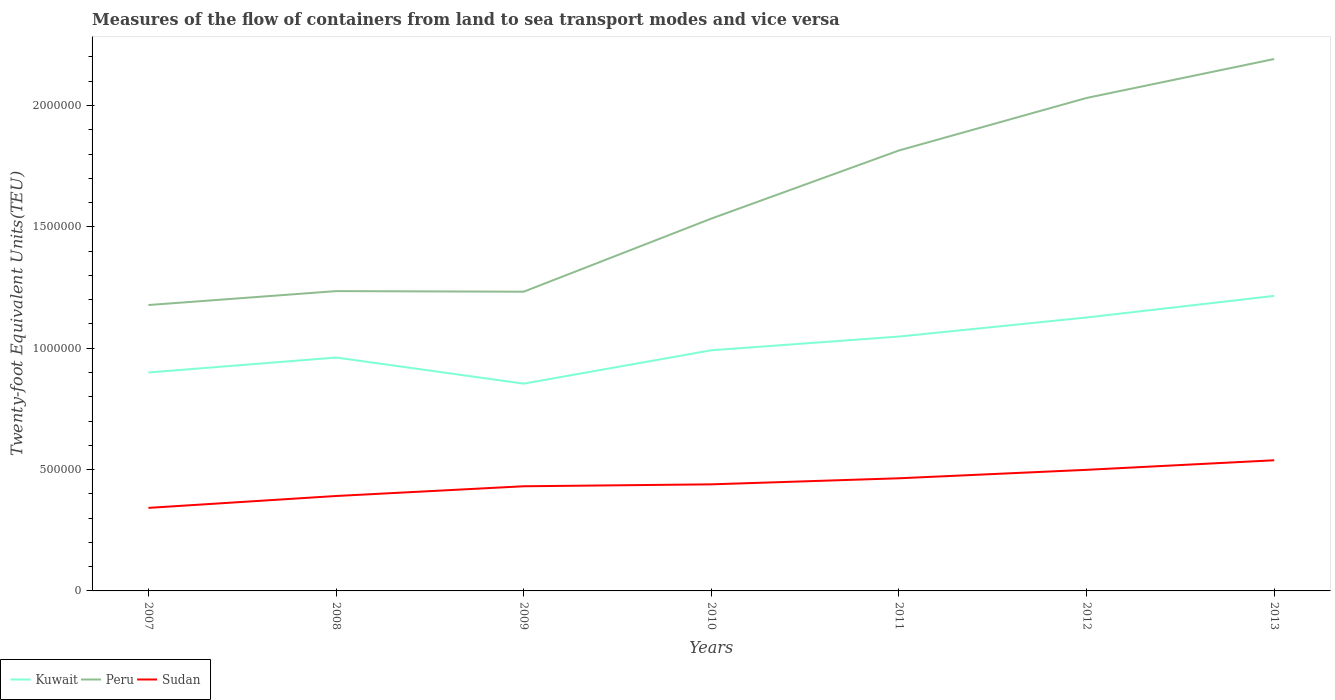Does the line corresponding to Kuwait intersect with the line corresponding to Sudan?
Your answer should be compact. No. Across all years, what is the maximum container port traffic in Kuwait?
Your response must be concise. 8.54e+05. What is the total container port traffic in Kuwait in the graph?
Your response must be concise. -1.35e+05. What is the difference between the highest and the second highest container port traffic in Peru?
Offer a very short reply. 1.01e+06. Is the container port traffic in Sudan strictly greater than the container port traffic in Peru over the years?
Your response must be concise. Yes. What is the difference between two consecutive major ticks on the Y-axis?
Give a very brief answer. 5.00e+05. Are the values on the major ticks of Y-axis written in scientific E-notation?
Your answer should be compact. No. Does the graph contain any zero values?
Your response must be concise. No. How many legend labels are there?
Make the answer very short. 3. What is the title of the graph?
Provide a succinct answer. Measures of the flow of containers from land to sea transport modes and vice versa. Does "Chad" appear as one of the legend labels in the graph?
Provide a short and direct response. No. What is the label or title of the X-axis?
Give a very brief answer. Years. What is the label or title of the Y-axis?
Make the answer very short. Twenty-foot Equivalent Units(TEU). What is the Twenty-foot Equivalent Units(TEU) of Peru in 2007?
Your answer should be compact. 1.18e+06. What is the Twenty-foot Equivalent Units(TEU) of Sudan in 2007?
Give a very brief answer. 3.42e+05. What is the Twenty-foot Equivalent Units(TEU) in Kuwait in 2008?
Keep it short and to the point. 9.62e+05. What is the Twenty-foot Equivalent Units(TEU) in Peru in 2008?
Provide a succinct answer. 1.24e+06. What is the Twenty-foot Equivalent Units(TEU) in Sudan in 2008?
Offer a terse response. 3.91e+05. What is the Twenty-foot Equivalent Units(TEU) in Kuwait in 2009?
Provide a short and direct response. 8.54e+05. What is the Twenty-foot Equivalent Units(TEU) in Peru in 2009?
Your response must be concise. 1.23e+06. What is the Twenty-foot Equivalent Units(TEU) in Sudan in 2009?
Ensure brevity in your answer.  4.31e+05. What is the Twenty-foot Equivalent Units(TEU) in Kuwait in 2010?
Provide a short and direct response. 9.92e+05. What is the Twenty-foot Equivalent Units(TEU) in Peru in 2010?
Keep it short and to the point. 1.53e+06. What is the Twenty-foot Equivalent Units(TEU) of Sudan in 2010?
Offer a terse response. 4.39e+05. What is the Twenty-foot Equivalent Units(TEU) of Kuwait in 2011?
Offer a terse response. 1.05e+06. What is the Twenty-foot Equivalent Units(TEU) in Peru in 2011?
Provide a short and direct response. 1.81e+06. What is the Twenty-foot Equivalent Units(TEU) of Sudan in 2011?
Your answer should be compact. 4.64e+05. What is the Twenty-foot Equivalent Units(TEU) in Kuwait in 2012?
Your response must be concise. 1.13e+06. What is the Twenty-foot Equivalent Units(TEU) in Peru in 2012?
Make the answer very short. 2.03e+06. What is the Twenty-foot Equivalent Units(TEU) of Sudan in 2012?
Provide a succinct answer. 4.99e+05. What is the Twenty-foot Equivalent Units(TEU) of Kuwait in 2013?
Your answer should be compact. 1.22e+06. What is the Twenty-foot Equivalent Units(TEU) in Peru in 2013?
Your answer should be compact. 2.19e+06. What is the Twenty-foot Equivalent Units(TEU) in Sudan in 2013?
Your answer should be compact. 5.38e+05. Across all years, what is the maximum Twenty-foot Equivalent Units(TEU) of Kuwait?
Your answer should be very brief. 1.22e+06. Across all years, what is the maximum Twenty-foot Equivalent Units(TEU) in Peru?
Offer a very short reply. 2.19e+06. Across all years, what is the maximum Twenty-foot Equivalent Units(TEU) of Sudan?
Your response must be concise. 5.38e+05. Across all years, what is the minimum Twenty-foot Equivalent Units(TEU) in Kuwait?
Your answer should be very brief. 8.54e+05. Across all years, what is the minimum Twenty-foot Equivalent Units(TEU) in Peru?
Provide a succinct answer. 1.18e+06. Across all years, what is the minimum Twenty-foot Equivalent Units(TEU) in Sudan?
Your response must be concise. 3.42e+05. What is the total Twenty-foot Equivalent Units(TEU) of Kuwait in the graph?
Give a very brief answer. 7.10e+06. What is the total Twenty-foot Equivalent Units(TEU) of Peru in the graph?
Ensure brevity in your answer.  1.12e+07. What is the total Twenty-foot Equivalent Units(TEU) in Sudan in the graph?
Give a very brief answer. 3.11e+06. What is the difference between the Twenty-foot Equivalent Units(TEU) of Kuwait in 2007 and that in 2008?
Give a very brief answer. -6.17e+04. What is the difference between the Twenty-foot Equivalent Units(TEU) in Peru in 2007 and that in 2008?
Your response must be concise. -5.74e+04. What is the difference between the Twenty-foot Equivalent Units(TEU) in Sudan in 2007 and that in 2008?
Your answer should be compact. -4.90e+04. What is the difference between the Twenty-foot Equivalent Units(TEU) in Kuwait in 2007 and that in 2009?
Offer a terse response. 4.60e+04. What is the difference between the Twenty-foot Equivalent Units(TEU) of Peru in 2007 and that in 2009?
Offer a very short reply. -5.49e+04. What is the difference between the Twenty-foot Equivalent Units(TEU) in Sudan in 2007 and that in 2009?
Provide a succinct answer. -8.91e+04. What is the difference between the Twenty-foot Equivalent Units(TEU) in Kuwait in 2007 and that in 2010?
Your answer should be very brief. -9.15e+04. What is the difference between the Twenty-foot Equivalent Units(TEU) in Peru in 2007 and that in 2010?
Provide a short and direct response. -3.56e+05. What is the difference between the Twenty-foot Equivalent Units(TEU) of Sudan in 2007 and that in 2010?
Your response must be concise. -9.69e+04. What is the difference between the Twenty-foot Equivalent Units(TEU) of Kuwait in 2007 and that in 2011?
Your response must be concise. -1.48e+05. What is the difference between the Twenty-foot Equivalent Units(TEU) of Peru in 2007 and that in 2011?
Your response must be concise. -6.37e+05. What is the difference between the Twenty-foot Equivalent Units(TEU) in Sudan in 2007 and that in 2011?
Keep it short and to the point. -1.22e+05. What is the difference between the Twenty-foot Equivalent Units(TEU) of Kuwait in 2007 and that in 2012?
Your answer should be compact. -2.27e+05. What is the difference between the Twenty-foot Equivalent Units(TEU) of Peru in 2007 and that in 2012?
Provide a succinct answer. -8.53e+05. What is the difference between the Twenty-foot Equivalent Units(TEU) in Sudan in 2007 and that in 2012?
Your response must be concise. -1.57e+05. What is the difference between the Twenty-foot Equivalent Units(TEU) of Kuwait in 2007 and that in 2013?
Ensure brevity in your answer.  -3.16e+05. What is the difference between the Twenty-foot Equivalent Units(TEU) of Peru in 2007 and that in 2013?
Your answer should be very brief. -1.01e+06. What is the difference between the Twenty-foot Equivalent Units(TEU) in Sudan in 2007 and that in 2013?
Make the answer very short. -1.96e+05. What is the difference between the Twenty-foot Equivalent Units(TEU) in Kuwait in 2008 and that in 2009?
Provide a succinct answer. 1.08e+05. What is the difference between the Twenty-foot Equivalent Units(TEU) of Peru in 2008 and that in 2009?
Your response must be concise. 2477. What is the difference between the Twenty-foot Equivalent Units(TEU) in Sudan in 2008 and that in 2009?
Your response must be concise. -4.01e+04. What is the difference between the Twenty-foot Equivalent Units(TEU) of Kuwait in 2008 and that in 2010?
Your response must be concise. -2.99e+04. What is the difference between the Twenty-foot Equivalent Units(TEU) in Peru in 2008 and that in 2010?
Provide a succinct answer. -2.99e+05. What is the difference between the Twenty-foot Equivalent Units(TEU) in Sudan in 2008 and that in 2010?
Your answer should be compact. -4.80e+04. What is the difference between the Twenty-foot Equivalent Units(TEU) of Kuwait in 2008 and that in 2011?
Give a very brief answer. -8.64e+04. What is the difference between the Twenty-foot Equivalent Units(TEU) of Peru in 2008 and that in 2011?
Keep it short and to the point. -5.79e+05. What is the difference between the Twenty-foot Equivalent Units(TEU) in Sudan in 2008 and that in 2011?
Your response must be concise. -7.30e+04. What is the difference between the Twenty-foot Equivalent Units(TEU) in Kuwait in 2008 and that in 2012?
Keep it short and to the point. -1.65e+05. What is the difference between the Twenty-foot Equivalent Units(TEU) in Peru in 2008 and that in 2012?
Provide a short and direct response. -7.96e+05. What is the difference between the Twenty-foot Equivalent Units(TEU) in Sudan in 2008 and that in 2012?
Your response must be concise. -1.08e+05. What is the difference between the Twenty-foot Equivalent Units(TEU) in Kuwait in 2008 and that in 2013?
Your response must be concise. -2.54e+05. What is the difference between the Twenty-foot Equivalent Units(TEU) in Peru in 2008 and that in 2013?
Make the answer very short. -9.56e+05. What is the difference between the Twenty-foot Equivalent Units(TEU) of Sudan in 2008 and that in 2013?
Your response must be concise. -1.47e+05. What is the difference between the Twenty-foot Equivalent Units(TEU) of Kuwait in 2009 and that in 2010?
Keep it short and to the point. -1.38e+05. What is the difference between the Twenty-foot Equivalent Units(TEU) of Peru in 2009 and that in 2010?
Make the answer very short. -3.01e+05. What is the difference between the Twenty-foot Equivalent Units(TEU) of Sudan in 2009 and that in 2010?
Offer a very short reply. -7868. What is the difference between the Twenty-foot Equivalent Units(TEU) in Kuwait in 2009 and that in 2011?
Your answer should be very brief. -1.94e+05. What is the difference between the Twenty-foot Equivalent Units(TEU) of Peru in 2009 and that in 2011?
Your answer should be very brief. -5.82e+05. What is the difference between the Twenty-foot Equivalent Units(TEU) of Sudan in 2009 and that in 2011?
Keep it short and to the point. -3.29e+04. What is the difference between the Twenty-foot Equivalent Units(TEU) of Kuwait in 2009 and that in 2012?
Your answer should be compact. -2.73e+05. What is the difference between the Twenty-foot Equivalent Units(TEU) of Peru in 2009 and that in 2012?
Provide a short and direct response. -7.98e+05. What is the difference between the Twenty-foot Equivalent Units(TEU) of Sudan in 2009 and that in 2012?
Provide a succinct answer. -6.77e+04. What is the difference between the Twenty-foot Equivalent Units(TEU) in Kuwait in 2009 and that in 2013?
Keep it short and to the point. -3.62e+05. What is the difference between the Twenty-foot Equivalent Units(TEU) in Peru in 2009 and that in 2013?
Provide a succinct answer. -9.59e+05. What is the difference between the Twenty-foot Equivalent Units(TEU) in Sudan in 2009 and that in 2013?
Your answer should be compact. -1.07e+05. What is the difference between the Twenty-foot Equivalent Units(TEU) in Kuwait in 2010 and that in 2011?
Make the answer very short. -5.65e+04. What is the difference between the Twenty-foot Equivalent Units(TEU) of Peru in 2010 and that in 2011?
Give a very brief answer. -2.81e+05. What is the difference between the Twenty-foot Equivalent Units(TEU) of Sudan in 2010 and that in 2011?
Provide a succinct answer. -2.50e+04. What is the difference between the Twenty-foot Equivalent Units(TEU) in Kuwait in 2010 and that in 2012?
Ensure brevity in your answer.  -1.35e+05. What is the difference between the Twenty-foot Equivalent Units(TEU) in Peru in 2010 and that in 2012?
Your response must be concise. -4.97e+05. What is the difference between the Twenty-foot Equivalent Units(TEU) of Sudan in 2010 and that in 2012?
Make the answer very short. -5.98e+04. What is the difference between the Twenty-foot Equivalent Units(TEU) in Kuwait in 2010 and that in 2013?
Your answer should be compact. -2.24e+05. What is the difference between the Twenty-foot Equivalent Units(TEU) of Peru in 2010 and that in 2013?
Provide a short and direct response. -6.58e+05. What is the difference between the Twenty-foot Equivalent Units(TEU) of Sudan in 2010 and that in 2013?
Your answer should be very brief. -9.93e+04. What is the difference between the Twenty-foot Equivalent Units(TEU) of Kuwait in 2011 and that in 2012?
Provide a short and direct response. -7.86e+04. What is the difference between the Twenty-foot Equivalent Units(TEU) of Peru in 2011 and that in 2012?
Your answer should be compact. -2.16e+05. What is the difference between the Twenty-foot Equivalent Units(TEU) in Sudan in 2011 and that in 2012?
Make the answer very short. -3.48e+04. What is the difference between the Twenty-foot Equivalent Units(TEU) in Kuwait in 2011 and that in 2013?
Provide a short and direct response. -1.68e+05. What is the difference between the Twenty-foot Equivalent Units(TEU) in Peru in 2011 and that in 2013?
Your response must be concise. -3.77e+05. What is the difference between the Twenty-foot Equivalent Units(TEU) of Sudan in 2011 and that in 2013?
Offer a terse response. -7.42e+04. What is the difference between the Twenty-foot Equivalent Units(TEU) in Kuwait in 2012 and that in 2013?
Your response must be concise. -8.90e+04. What is the difference between the Twenty-foot Equivalent Units(TEU) in Peru in 2012 and that in 2013?
Offer a terse response. -1.60e+05. What is the difference between the Twenty-foot Equivalent Units(TEU) of Sudan in 2012 and that in 2013?
Ensure brevity in your answer.  -3.94e+04. What is the difference between the Twenty-foot Equivalent Units(TEU) in Kuwait in 2007 and the Twenty-foot Equivalent Units(TEU) in Peru in 2008?
Your response must be concise. -3.35e+05. What is the difference between the Twenty-foot Equivalent Units(TEU) in Kuwait in 2007 and the Twenty-foot Equivalent Units(TEU) in Sudan in 2008?
Your answer should be compact. 5.09e+05. What is the difference between the Twenty-foot Equivalent Units(TEU) in Peru in 2007 and the Twenty-foot Equivalent Units(TEU) in Sudan in 2008?
Offer a terse response. 7.87e+05. What is the difference between the Twenty-foot Equivalent Units(TEU) in Kuwait in 2007 and the Twenty-foot Equivalent Units(TEU) in Peru in 2009?
Your answer should be very brief. -3.33e+05. What is the difference between the Twenty-foot Equivalent Units(TEU) in Kuwait in 2007 and the Twenty-foot Equivalent Units(TEU) in Sudan in 2009?
Offer a very short reply. 4.69e+05. What is the difference between the Twenty-foot Equivalent Units(TEU) in Peru in 2007 and the Twenty-foot Equivalent Units(TEU) in Sudan in 2009?
Make the answer very short. 7.47e+05. What is the difference between the Twenty-foot Equivalent Units(TEU) in Kuwait in 2007 and the Twenty-foot Equivalent Units(TEU) in Peru in 2010?
Keep it short and to the point. -6.34e+05. What is the difference between the Twenty-foot Equivalent Units(TEU) of Kuwait in 2007 and the Twenty-foot Equivalent Units(TEU) of Sudan in 2010?
Provide a short and direct response. 4.61e+05. What is the difference between the Twenty-foot Equivalent Units(TEU) in Peru in 2007 and the Twenty-foot Equivalent Units(TEU) in Sudan in 2010?
Offer a terse response. 7.39e+05. What is the difference between the Twenty-foot Equivalent Units(TEU) of Kuwait in 2007 and the Twenty-foot Equivalent Units(TEU) of Peru in 2011?
Provide a short and direct response. -9.15e+05. What is the difference between the Twenty-foot Equivalent Units(TEU) of Kuwait in 2007 and the Twenty-foot Equivalent Units(TEU) of Sudan in 2011?
Offer a very short reply. 4.36e+05. What is the difference between the Twenty-foot Equivalent Units(TEU) in Peru in 2007 and the Twenty-foot Equivalent Units(TEU) in Sudan in 2011?
Make the answer very short. 7.14e+05. What is the difference between the Twenty-foot Equivalent Units(TEU) in Kuwait in 2007 and the Twenty-foot Equivalent Units(TEU) in Peru in 2012?
Provide a succinct answer. -1.13e+06. What is the difference between the Twenty-foot Equivalent Units(TEU) of Kuwait in 2007 and the Twenty-foot Equivalent Units(TEU) of Sudan in 2012?
Offer a very short reply. 4.01e+05. What is the difference between the Twenty-foot Equivalent Units(TEU) of Peru in 2007 and the Twenty-foot Equivalent Units(TEU) of Sudan in 2012?
Your answer should be very brief. 6.79e+05. What is the difference between the Twenty-foot Equivalent Units(TEU) in Kuwait in 2007 and the Twenty-foot Equivalent Units(TEU) in Peru in 2013?
Your answer should be very brief. -1.29e+06. What is the difference between the Twenty-foot Equivalent Units(TEU) of Kuwait in 2007 and the Twenty-foot Equivalent Units(TEU) of Sudan in 2013?
Make the answer very short. 3.62e+05. What is the difference between the Twenty-foot Equivalent Units(TEU) in Peru in 2007 and the Twenty-foot Equivalent Units(TEU) in Sudan in 2013?
Provide a short and direct response. 6.40e+05. What is the difference between the Twenty-foot Equivalent Units(TEU) in Kuwait in 2008 and the Twenty-foot Equivalent Units(TEU) in Peru in 2009?
Offer a very short reply. -2.71e+05. What is the difference between the Twenty-foot Equivalent Units(TEU) of Kuwait in 2008 and the Twenty-foot Equivalent Units(TEU) of Sudan in 2009?
Provide a succinct answer. 5.30e+05. What is the difference between the Twenty-foot Equivalent Units(TEU) in Peru in 2008 and the Twenty-foot Equivalent Units(TEU) in Sudan in 2009?
Your answer should be compact. 8.04e+05. What is the difference between the Twenty-foot Equivalent Units(TEU) of Kuwait in 2008 and the Twenty-foot Equivalent Units(TEU) of Peru in 2010?
Offer a terse response. -5.72e+05. What is the difference between the Twenty-foot Equivalent Units(TEU) of Kuwait in 2008 and the Twenty-foot Equivalent Units(TEU) of Sudan in 2010?
Give a very brief answer. 5.23e+05. What is the difference between the Twenty-foot Equivalent Units(TEU) in Peru in 2008 and the Twenty-foot Equivalent Units(TEU) in Sudan in 2010?
Provide a succinct answer. 7.96e+05. What is the difference between the Twenty-foot Equivalent Units(TEU) of Kuwait in 2008 and the Twenty-foot Equivalent Units(TEU) of Peru in 2011?
Your answer should be very brief. -8.53e+05. What is the difference between the Twenty-foot Equivalent Units(TEU) in Kuwait in 2008 and the Twenty-foot Equivalent Units(TEU) in Sudan in 2011?
Provide a succinct answer. 4.98e+05. What is the difference between the Twenty-foot Equivalent Units(TEU) in Peru in 2008 and the Twenty-foot Equivalent Units(TEU) in Sudan in 2011?
Give a very brief answer. 7.71e+05. What is the difference between the Twenty-foot Equivalent Units(TEU) in Kuwait in 2008 and the Twenty-foot Equivalent Units(TEU) in Peru in 2012?
Make the answer very short. -1.07e+06. What is the difference between the Twenty-foot Equivalent Units(TEU) of Kuwait in 2008 and the Twenty-foot Equivalent Units(TEU) of Sudan in 2012?
Provide a succinct answer. 4.63e+05. What is the difference between the Twenty-foot Equivalent Units(TEU) in Peru in 2008 and the Twenty-foot Equivalent Units(TEU) in Sudan in 2012?
Your response must be concise. 7.36e+05. What is the difference between the Twenty-foot Equivalent Units(TEU) of Kuwait in 2008 and the Twenty-foot Equivalent Units(TEU) of Peru in 2013?
Offer a terse response. -1.23e+06. What is the difference between the Twenty-foot Equivalent Units(TEU) of Kuwait in 2008 and the Twenty-foot Equivalent Units(TEU) of Sudan in 2013?
Provide a short and direct response. 4.23e+05. What is the difference between the Twenty-foot Equivalent Units(TEU) of Peru in 2008 and the Twenty-foot Equivalent Units(TEU) of Sudan in 2013?
Make the answer very short. 6.97e+05. What is the difference between the Twenty-foot Equivalent Units(TEU) in Kuwait in 2009 and the Twenty-foot Equivalent Units(TEU) in Peru in 2010?
Provide a short and direct response. -6.80e+05. What is the difference between the Twenty-foot Equivalent Units(TEU) in Kuwait in 2009 and the Twenty-foot Equivalent Units(TEU) in Sudan in 2010?
Offer a very short reply. 4.15e+05. What is the difference between the Twenty-foot Equivalent Units(TEU) of Peru in 2009 and the Twenty-foot Equivalent Units(TEU) of Sudan in 2010?
Ensure brevity in your answer.  7.94e+05. What is the difference between the Twenty-foot Equivalent Units(TEU) of Kuwait in 2009 and the Twenty-foot Equivalent Units(TEU) of Peru in 2011?
Keep it short and to the point. -9.61e+05. What is the difference between the Twenty-foot Equivalent Units(TEU) of Kuwait in 2009 and the Twenty-foot Equivalent Units(TEU) of Sudan in 2011?
Provide a short and direct response. 3.90e+05. What is the difference between the Twenty-foot Equivalent Units(TEU) in Peru in 2009 and the Twenty-foot Equivalent Units(TEU) in Sudan in 2011?
Your response must be concise. 7.69e+05. What is the difference between the Twenty-foot Equivalent Units(TEU) in Kuwait in 2009 and the Twenty-foot Equivalent Units(TEU) in Peru in 2012?
Make the answer very short. -1.18e+06. What is the difference between the Twenty-foot Equivalent Units(TEU) of Kuwait in 2009 and the Twenty-foot Equivalent Units(TEU) of Sudan in 2012?
Provide a succinct answer. 3.55e+05. What is the difference between the Twenty-foot Equivalent Units(TEU) in Peru in 2009 and the Twenty-foot Equivalent Units(TEU) in Sudan in 2012?
Offer a terse response. 7.34e+05. What is the difference between the Twenty-foot Equivalent Units(TEU) of Kuwait in 2009 and the Twenty-foot Equivalent Units(TEU) of Peru in 2013?
Your response must be concise. -1.34e+06. What is the difference between the Twenty-foot Equivalent Units(TEU) in Kuwait in 2009 and the Twenty-foot Equivalent Units(TEU) in Sudan in 2013?
Make the answer very short. 3.16e+05. What is the difference between the Twenty-foot Equivalent Units(TEU) of Peru in 2009 and the Twenty-foot Equivalent Units(TEU) of Sudan in 2013?
Provide a short and direct response. 6.94e+05. What is the difference between the Twenty-foot Equivalent Units(TEU) of Kuwait in 2010 and the Twenty-foot Equivalent Units(TEU) of Peru in 2011?
Offer a very short reply. -8.23e+05. What is the difference between the Twenty-foot Equivalent Units(TEU) in Kuwait in 2010 and the Twenty-foot Equivalent Units(TEU) in Sudan in 2011?
Your response must be concise. 5.27e+05. What is the difference between the Twenty-foot Equivalent Units(TEU) of Peru in 2010 and the Twenty-foot Equivalent Units(TEU) of Sudan in 2011?
Keep it short and to the point. 1.07e+06. What is the difference between the Twenty-foot Equivalent Units(TEU) in Kuwait in 2010 and the Twenty-foot Equivalent Units(TEU) in Peru in 2012?
Your answer should be compact. -1.04e+06. What is the difference between the Twenty-foot Equivalent Units(TEU) in Kuwait in 2010 and the Twenty-foot Equivalent Units(TEU) in Sudan in 2012?
Provide a short and direct response. 4.93e+05. What is the difference between the Twenty-foot Equivalent Units(TEU) in Peru in 2010 and the Twenty-foot Equivalent Units(TEU) in Sudan in 2012?
Ensure brevity in your answer.  1.04e+06. What is the difference between the Twenty-foot Equivalent Units(TEU) in Kuwait in 2010 and the Twenty-foot Equivalent Units(TEU) in Peru in 2013?
Your response must be concise. -1.20e+06. What is the difference between the Twenty-foot Equivalent Units(TEU) of Kuwait in 2010 and the Twenty-foot Equivalent Units(TEU) of Sudan in 2013?
Provide a succinct answer. 4.53e+05. What is the difference between the Twenty-foot Equivalent Units(TEU) in Peru in 2010 and the Twenty-foot Equivalent Units(TEU) in Sudan in 2013?
Your answer should be compact. 9.96e+05. What is the difference between the Twenty-foot Equivalent Units(TEU) in Kuwait in 2011 and the Twenty-foot Equivalent Units(TEU) in Peru in 2012?
Offer a terse response. -9.83e+05. What is the difference between the Twenty-foot Equivalent Units(TEU) in Kuwait in 2011 and the Twenty-foot Equivalent Units(TEU) in Sudan in 2012?
Make the answer very short. 5.49e+05. What is the difference between the Twenty-foot Equivalent Units(TEU) in Peru in 2011 and the Twenty-foot Equivalent Units(TEU) in Sudan in 2012?
Give a very brief answer. 1.32e+06. What is the difference between the Twenty-foot Equivalent Units(TEU) of Kuwait in 2011 and the Twenty-foot Equivalent Units(TEU) of Peru in 2013?
Make the answer very short. -1.14e+06. What is the difference between the Twenty-foot Equivalent Units(TEU) of Kuwait in 2011 and the Twenty-foot Equivalent Units(TEU) of Sudan in 2013?
Offer a terse response. 5.10e+05. What is the difference between the Twenty-foot Equivalent Units(TEU) of Peru in 2011 and the Twenty-foot Equivalent Units(TEU) of Sudan in 2013?
Offer a very short reply. 1.28e+06. What is the difference between the Twenty-foot Equivalent Units(TEU) of Kuwait in 2012 and the Twenty-foot Equivalent Units(TEU) of Peru in 2013?
Provide a short and direct response. -1.06e+06. What is the difference between the Twenty-foot Equivalent Units(TEU) in Kuwait in 2012 and the Twenty-foot Equivalent Units(TEU) in Sudan in 2013?
Your response must be concise. 5.88e+05. What is the difference between the Twenty-foot Equivalent Units(TEU) of Peru in 2012 and the Twenty-foot Equivalent Units(TEU) of Sudan in 2013?
Provide a succinct answer. 1.49e+06. What is the average Twenty-foot Equivalent Units(TEU) in Kuwait per year?
Offer a very short reply. 1.01e+06. What is the average Twenty-foot Equivalent Units(TEU) in Peru per year?
Ensure brevity in your answer.  1.60e+06. What is the average Twenty-foot Equivalent Units(TEU) in Sudan per year?
Your answer should be compact. 4.44e+05. In the year 2007, what is the difference between the Twenty-foot Equivalent Units(TEU) of Kuwait and Twenty-foot Equivalent Units(TEU) of Peru?
Keep it short and to the point. -2.78e+05. In the year 2007, what is the difference between the Twenty-foot Equivalent Units(TEU) in Kuwait and Twenty-foot Equivalent Units(TEU) in Sudan?
Ensure brevity in your answer.  5.58e+05. In the year 2007, what is the difference between the Twenty-foot Equivalent Units(TEU) of Peru and Twenty-foot Equivalent Units(TEU) of Sudan?
Keep it short and to the point. 8.36e+05. In the year 2008, what is the difference between the Twenty-foot Equivalent Units(TEU) of Kuwait and Twenty-foot Equivalent Units(TEU) of Peru?
Offer a terse response. -2.74e+05. In the year 2008, what is the difference between the Twenty-foot Equivalent Units(TEU) of Kuwait and Twenty-foot Equivalent Units(TEU) of Sudan?
Your answer should be very brief. 5.71e+05. In the year 2008, what is the difference between the Twenty-foot Equivalent Units(TEU) in Peru and Twenty-foot Equivalent Units(TEU) in Sudan?
Your answer should be compact. 8.44e+05. In the year 2009, what is the difference between the Twenty-foot Equivalent Units(TEU) in Kuwait and Twenty-foot Equivalent Units(TEU) in Peru?
Your answer should be very brief. -3.79e+05. In the year 2009, what is the difference between the Twenty-foot Equivalent Units(TEU) of Kuwait and Twenty-foot Equivalent Units(TEU) of Sudan?
Make the answer very short. 4.23e+05. In the year 2009, what is the difference between the Twenty-foot Equivalent Units(TEU) of Peru and Twenty-foot Equivalent Units(TEU) of Sudan?
Provide a short and direct response. 8.02e+05. In the year 2010, what is the difference between the Twenty-foot Equivalent Units(TEU) in Kuwait and Twenty-foot Equivalent Units(TEU) in Peru?
Provide a short and direct response. -5.43e+05. In the year 2010, what is the difference between the Twenty-foot Equivalent Units(TEU) of Kuwait and Twenty-foot Equivalent Units(TEU) of Sudan?
Keep it short and to the point. 5.52e+05. In the year 2010, what is the difference between the Twenty-foot Equivalent Units(TEU) in Peru and Twenty-foot Equivalent Units(TEU) in Sudan?
Make the answer very short. 1.09e+06. In the year 2011, what is the difference between the Twenty-foot Equivalent Units(TEU) of Kuwait and Twenty-foot Equivalent Units(TEU) of Peru?
Give a very brief answer. -7.67e+05. In the year 2011, what is the difference between the Twenty-foot Equivalent Units(TEU) of Kuwait and Twenty-foot Equivalent Units(TEU) of Sudan?
Your response must be concise. 5.84e+05. In the year 2011, what is the difference between the Twenty-foot Equivalent Units(TEU) of Peru and Twenty-foot Equivalent Units(TEU) of Sudan?
Keep it short and to the point. 1.35e+06. In the year 2012, what is the difference between the Twenty-foot Equivalent Units(TEU) of Kuwait and Twenty-foot Equivalent Units(TEU) of Peru?
Ensure brevity in your answer.  -9.04e+05. In the year 2012, what is the difference between the Twenty-foot Equivalent Units(TEU) of Kuwait and Twenty-foot Equivalent Units(TEU) of Sudan?
Offer a terse response. 6.28e+05. In the year 2012, what is the difference between the Twenty-foot Equivalent Units(TEU) of Peru and Twenty-foot Equivalent Units(TEU) of Sudan?
Give a very brief answer. 1.53e+06. In the year 2013, what is the difference between the Twenty-foot Equivalent Units(TEU) of Kuwait and Twenty-foot Equivalent Units(TEU) of Peru?
Provide a succinct answer. -9.76e+05. In the year 2013, what is the difference between the Twenty-foot Equivalent Units(TEU) in Kuwait and Twenty-foot Equivalent Units(TEU) in Sudan?
Your answer should be compact. 6.77e+05. In the year 2013, what is the difference between the Twenty-foot Equivalent Units(TEU) in Peru and Twenty-foot Equivalent Units(TEU) in Sudan?
Keep it short and to the point. 1.65e+06. What is the ratio of the Twenty-foot Equivalent Units(TEU) of Kuwait in 2007 to that in 2008?
Offer a very short reply. 0.94. What is the ratio of the Twenty-foot Equivalent Units(TEU) of Peru in 2007 to that in 2008?
Give a very brief answer. 0.95. What is the ratio of the Twenty-foot Equivalent Units(TEU) in Sudan in 2007 to that in 2008?
Make the answer very short. 0.87. What is the ratio of the Twenty-foot Equivalent Units(TEU) in Kuwait in 2007 to that in 2009?
Give a very brief answer. 1.05. What is the ratio of the Twenty-foot Equivalent Units(TEU) in Peru in 2007 to that in 2009?
Offer a very short reply. 0.96. What is the ratio of the Twenty-foot Equivalent Units(TEU) of Sudan in 2007 to that in 2009?
Make the answer very short. 0.79. What is the ratio of the Twenty-foot Equivalent Units(TEU) of Kuwait in 2007 to that in 2010?
Your answer should be very brief. 0.91. What is the ratio of the Twenty-foot Equivalent Units(TEU) of Peru in 2007 to that in 2010?
Your response must be concise. 0.77. What is the ratio of the Twenty-foot Equivalent Units(TEU) in Sudan in 2007 to that in 2010?
Keep it short and to the point. 0.78. What is the ratio of the Twenty-foot Equivalent Units(TEU) in Kuwait in 2007 to that in 2011?
Your response must be concise. 0.86. What is the ratio of the Twenty-foot Equivalent Units(TEU) of Peru in 2007 to that in 2011?
Offer a terse response. 0.65. What is the ratio of the Twenty-foot Equivalent Units(TEU) in Sudan in 2007 to that in 2011?
Give a very brief answer. 0.74. What is the ratio of the Twenty-foot Equivalent Units(TEU) in Kuwait in 2007 to that in 2012?
Provide a succinct answer. 0.8. What is the ratio of the Twenty-foot Equivalent Units(TEU) of Peru in 2007 to that in 2012?
Give a very brief answer. 0.58. What is the ratio of the Twenty-foot Equivalent Units(TEU) of Sudan in 2007 to that in 2012?
Provide a succinct answer. 0.69. What is the ratio of the Twenty-foot Equivalent Units(TEU) of Kuwait in 2007 to that in 2013?
Provide a short and direct response. 0.74. What is the ratio of the Twenty-foot Equivalent Units(TEU) in Peru in 2007 to that in 2013?
Provide a short and direct response. 0.54. What is the ratio of the Twenty-foot Equivalent Units(TEU) of Sudan in 2007 to that in 2013?
Provide a succinct answer. 0.64. What is the ratio of the Twenty-foot Equivalent Units(TEU) of Kuwait in 2008 to that in 2009?
Your answer should be very brief. 1.13. What is the ratio of the Twenty-foot Equivalent Units(TEU) of Sudan in 2008 to that in 2009?
Provide a short and direct response. 0.91. What is the ratio of the Twenty-foot Equivalent Units(TEU) in Kuwait in 2008 to that in 2010?
Make the answer very short. 0.97. What is the ratio of the Twenty-foot Equivalent Units(TEU) in Peru in 2008 to that in 2010?
Your answer should be very brief. 0.81. What is the ratio of the Twenty-foot Equivalent Units(TEU) of Sudan in 2008 to that in 2010?
Your answer should be compact. 0.89. What is the ratio of the Twenty-foot Equivalent Units(TEU) of Kuwait in 2008 to that in 2011?
Keep it short and to the point. 0.92. What is the ratio of the Twenty-foot Equivalent Units(TEU) of Peru in 2008 to that in 2011?
Your answer should be compact. 0.68. What is the ratio of the Twenty-foot Equivalent Units(TEU) of Sudan in 2008 to that in 2011?
Your answer should be very brief. 0.84. What is the ratio of the Twenty-foot Equivalent Units(TEU) in Kuwait in 2008 to that in 2012?
Your response must be concise. 0.85. What is the ratio of the Twenty-foot Equivalent Units(TEU) of Peru in 2008 to that in 2012?
Offer a very short reply. 0.61. What is the ratio of the Twenty-foot Equivalent Units(TEU) in Sudan in 2008 to that in 2012?
Offer a terse response. 0.78. What is the ratio of the Twenty-foot Equivalent Units(TEU) of Kuwait in 2008 to that in 2013?
Offer a terse response. 0.79. What is the ratio of the Twenty-foot Equivalent Units(TEU) of Peru in 2008 to that in 2013?
Offer a terse response. 0.56. What is the ratio of the Twenty-foot Equivalent Units(TEU) in Sudan in 2008 to that in 2013?
Provide a short and direct response. 0.73. What is the ratio of the Twenty-foot Equivalent Units(TEU) of Kuwait in 2009 to that in 2010?
Ensure brevity in your answer.  0.86. What is the ratio of the Twenty-foot Equivalent Units(TEU) of Peru in 2009 to that in 2010?
Offer a very short reply. 0.8. What is the ratio of the Twenty-foot Equivalent Units(TEU) of Sudan in 2009 to that in 2010?
Provide a short and direct response. 0.98. What is the ratio of the Twenty-foot Equivalent Units(TEU) of Kuwait in 2009 to that in 2011?
Your answer should be very brief. 0.81. What is the ratio of the Twenty-foot Equivalent Units(TEU) in Peru in 2009 to that in 2011?
Keep it short and to the point. 0.68. What is the ratio of the Twenty-foot Equivalent Units(TEU) of Sudan in 2009 to that in 2011?
Keep it short and to the point. 0.93. What is the ratio of the Twenty-foot Equivalent Units(TEU) of Kuwait in 2009 to that in 2012?
Keep it short and to the point. 0.76. What is the ratio of the Twenty-foot Equivalent Units(TEU) in Peru in 2009 to that in 2012?
Keep it short and to the point. 0.61. What is the ratio of the Twenty-foot Equivalent Units(TEU) in Sudan in 2009 to that in 2012?
Give a very brief answer. 0.86. What is the ratio of the Twenty-foot Equivalent Units(TEU) of Kuwait in 2009 to that in 2013?
Ensure brevity in your answer.  0.7. What is the ratio of the Twenty-foot Equivalent Units(TEU) of Peru in 2009 to that in 2013?
Make the answer very short. 0.56. What is the ratio of the Twenty-foot Equivalent Units(TEU) of Sudan in 2009 to that in 2013?
Make the answer very short. 0.8. What is the ratio of the Twenty-foot Equivalent Units(TEU) in Kuwait in 2010 to that in 2011?
Make the answer very short. 0.95. What is the ratio of the Twenty-foot Equivalent Units(TEU) in Peru in 2010 to that in 2011?
Keep it short and to the point. 0.85. What is the ratio of the Twenty-foot Equivalent Units(TEU) in Sudan in 2010 to that in 2011?
Make the answer very short. 0.95. What is the ratio of the Twenty-foot Equivalent Units(TEU) in Kuwait in 2010 to that in 2012?
Offer a terse response. 0.88. What is the ratio of the Twenty-foot Equivalent Units(TEU) in Peru in 2010 to that in 2012?
Provide a succinct answer. 0.76. What is the ratio of the Twenty-foot Equivalent Units(TEU) in Sudan in 2010 to that in 2012?
Provide a succinct answer. 0.88. What is the ratio of the Twenty-foot Equivalent Units(TEU) in Kuwait in 2010 to that in 2013?
Ensure brevity in your answer.  0.82. What is the ratio of the Twenty-foot Equivalent Units(TEU) of Peru in 2010 to that in 2013?
Provide a short and direct response. 0.7. What is the ratio of the Twenty-foot Equivalent Units(TEU) in Sudan in 2010 to that in 2013?
Your answer should be very brief. 0.82. What is the ratio of the Twenty-foot Equivalent Units(TEU) of Kuwait in 2011 to that in 2012?
Provide a short and direct response. 0.93. What is the ratio of the Twenty-foot Equivalent Units(TEU) of Peru in 2011 to that in 2012?
Offer a terse response. 0.89. What is the ratio of the Twenty-foot Equivalent Units(TEU) in Sudan in 2011 to that in 2012?
Offer a very short reply. 0.93. What is the ratio of the Twenty-foot Equivalent Units(TEU) in Kuwait in 2011 to that in 2013?
Give a very brief answer. 0.86. What is the ratio of the Twenty-foot Equivalent Units(TEU) of Peru in 2011 to that in 2013?
Your answer should be compact. 0.83. What is the ratio of the Twenty-foot Equivalent Units(TEU) in Sudan in 2011 to that in 2013?
Your response must be concise. 0.86. What is the ratio of the Twenty-foot Equivalent Units(TEU) of Kuwait in 2012 to that in 2013?
Keep it short and to the point. 0.93. What is the ratio of the Twenty-foot Equivalent Units(TEU) in Peru in 2012 to that in 2013?
Offer a very short reply. 0.93. What is the ratio of the Twenty-foot Equivalent Units(TEU) of Sudan in 2012 to that in 2013?
Provide a succinct answer. 0.93. What is the difference between the highest and the second highest Twenty-foot Equivalent Units(TEU) of Kuwait?
Give a very brief answer. 8.90e+04. What is the difference between the highest and the second highest Twenty-foot Equivalent Units(TEU) in Peru?
Ensure brevity in your answer.  1.60e+05. What is the difference between the highest and the second highest Twenty-foot Equivalent Units(TEU) of Sudan?
Your answer should be compact. 3.94e+04. What is the difference between the highest and the lowest Twenty-foot Equivalent Units(TEU) of Kuwait?
Offer a very short reply. 3.62e+05. What is the difference between the highest and the lowest Twenty-foot Equivalent Units(TEU) of Peru?
Your answer should be compact. 1.01e+06. What is the difference between the highest and the lowest Twenty-foot Equivalent Units(TEU) of Sudan?
Make the answer very short. 1.96e+05. 